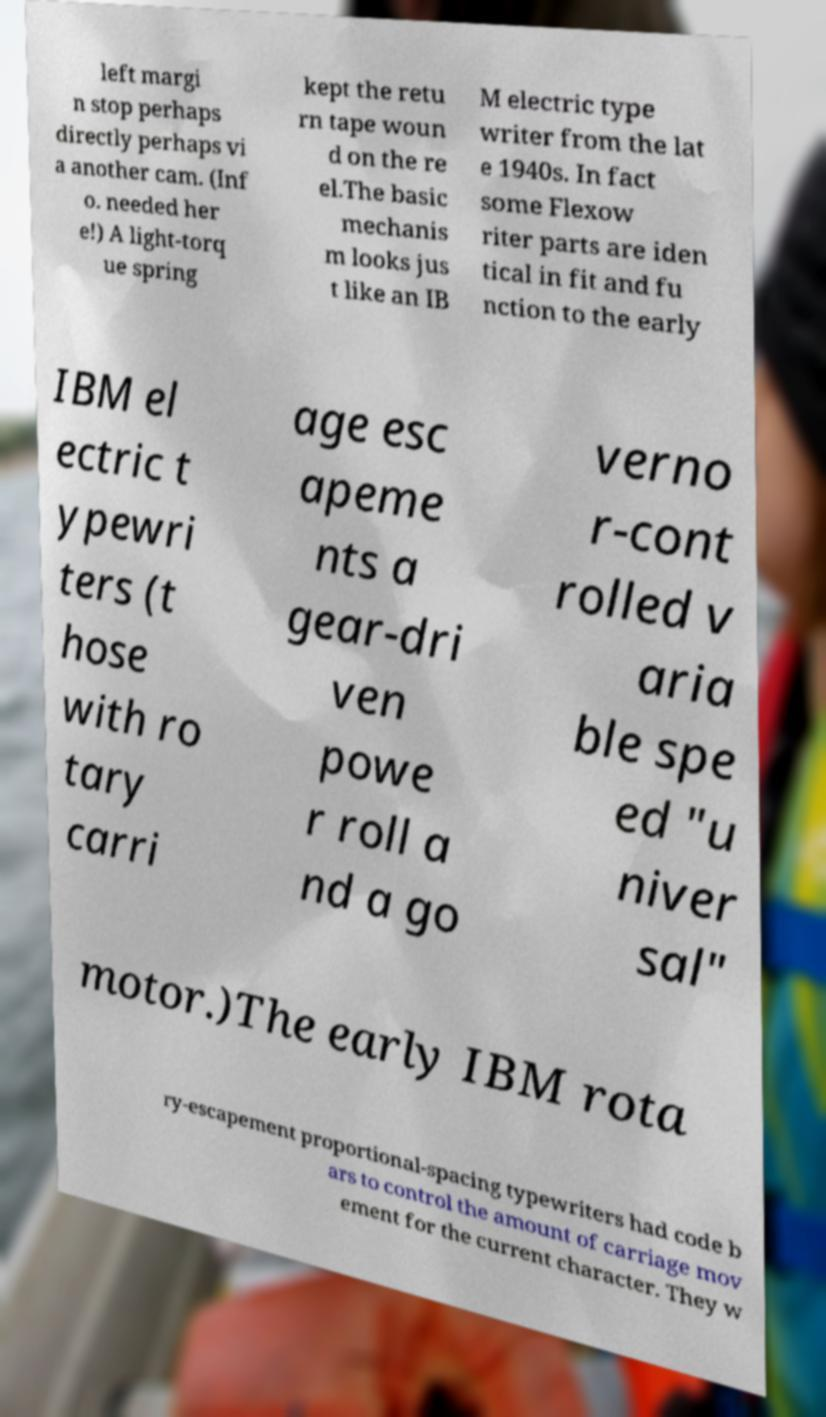Please identify and transcribe the text found in this image. left margi n stop perhaps directly perhaps vi a another cam. (Inf o. needed her e!) A light-torq ue spring kept the retu rn tape woun d on the re el.The basic mechanis m looks jus t like an IB M electric type writer from the lat e 1940s. In fact some Flexow riter parts are iden tical in fit and fu nction to the early IBM el ectric t ypewri ters (t hose with ro tary carri age esc apeme nts a gear-dri ven powe r roll a nd a go verno r-cont rolled v aria ble spe ed "u niver sal" motor.)The early IBM rota ry-escapement proportional-spacing typewriters had code b ars to control the amount of carriage mov ement for the current character. They w 